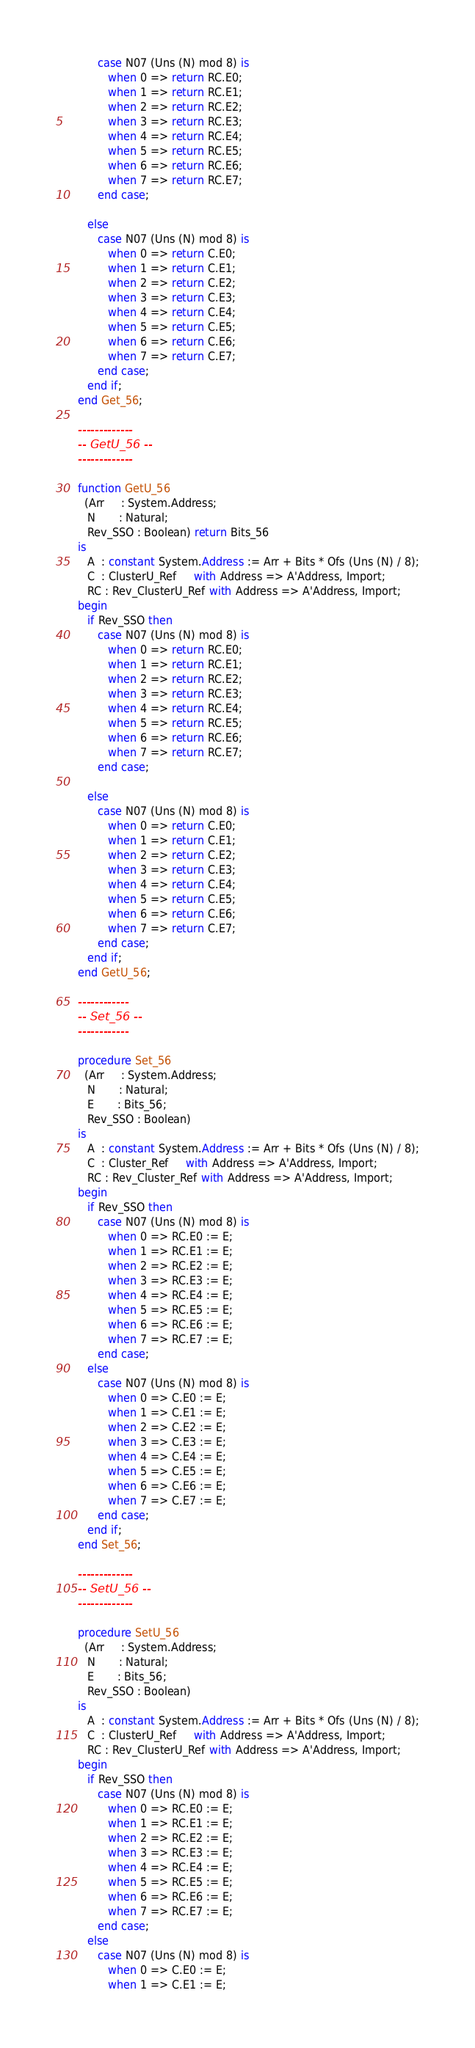<code> <loc_0><loc_0><loc_500><loc_500><_Ada_>         case N07 (Uns (N) mod 8) is
            when 0 => return RC.E0;
            when 1 => return RC.E1;
            when 2 => return RC.E2;
            when 3 => return RC.E3;
            when 4 => return RC.E4;
            when 5 => return RC.E5;
            when 6 => return RC.E6;
            when 7 => return RC.E7;
         end case;

      else
         case N07 (Uns (N) mod 8) is
            when 0 => return C.E0;
            when 1 => return C.E1;
            when 2 => return C.E2;
            when 3 => return C.E3;
            when 4 => return C.E4;
            when 5 => return C.E5;
            when 6 => return C.E6;
            when 7 => return C.E7;
         end case;
      end if;
   end Get_56;

   -------------
   -- GetU_56 --
   -------------

   function GetU_56
     (Arr     : System.Address;
      N       : Natural;
      Rev_SSO : Boolean) return Bits_56
   is
      A  : constant System.Address := Arr + Bits * Ofs (Uns (N) / 8);
      C  : ClusterU_Ref     with Address => A'Address, Import;
      RC : Rev_ClusterU_Ref with Address => A'Address, Import;
   begin
      if Rev_SSO then
         case N07 (Uns (N) mod 8) is
            when 0 => return RC.E0;
            when 1 => return RC.E1;
            when 2 => return RC.E2;
            when 3 => return RC.E3;
            when 4 => return RC.E4;
            when 5 => return RC.E5;
            when 6 => return RC.E6;
            when 7 => return RC.E7;
         end case;

      else
         case N07 (Uns (N) mod 8) is
            when 0 => return C.E0;
            when 1 => return C.E1;
            when 2 => return C.E2;
            when 3 => return C.E3;
            when 4 => return C.E4;
            when 5 => return C.E5;
            when 6 => return C.E6;
            when 7 => return C.E7;
         end case;
      end if;
   end GetU_56;

   ------------
   -- Set_56 --
   ------------

   procedure Set_56
     (Arr     : System.Address;
      N       : Natural;
      E       : Bits_56;
      Rev_SSO : Boolean)
   is
      A  : constant System.Address := Arr + Bits * Ofs (Uns (N) / 8);
      C  : Cluster_Ref     with Address => A'Address, Import;
      RC : Rev_Cluster_Ref with Address => A'Address, Import;
   begin
      if Rev_SSO then
         case N07 (Uns (N) mod 8) is
            when 0 => RC.E0 := E;
            when 1 => RC.E1 := E;
            when 2 => RC.E2 := E;
            when 3 => RC.E3 := E;
            when 4 => RC.E4 := E;
            when 5 => RC.E5 := E;
            when 6 => RC.E6 := E;
            when 7 => RC.E7 := E;
         end case;
      else
         case N07 (Uns (N) mod 8) is
            when 0 => C.E0 := E;
            when 1 => C.E1 := E;
            when 2 => C.E2 := E;
            when 3 => C.E3 := E;
            when 4 => C.E4 := E;
            when 5 => C.E5 := E;
            when 6 => C.E6 := E;
            when 7 => C.E7 := E;
         end case;
      end if;
   end Set_56;

   -------------
   -- SetU_56 --
   -------------

   procedure SetU_56
     (Arr     : System.Address;
      N       : Natural;
      E       : Bits_56;
      Rev_SSO : Boolean)
   is
      A  : constant System.Address := Arr + Bits * Ofs (Uns (N) / 8);
      C  : ClusterU_Ref     with Address => A'Address, Import;
      RC : Rev_ClusterU_Ref with Address => A'Address, Import;
   begin
      if Rev_SSO then
         case N07 (Uns (N) mod 8) is
            when 0 => RC.E0 := E;
            when 1 => RC.E1 := E;
            when 2 => RC.E2 := E;
            when 3 => RC.E3 := E;
            when 4 => RC.E4 := E;
            when 5 => RC.E5 := E;
            when 6 => RC.E6 := E;
            when 7 => RC.E7 := E;
         end case;
      else
         case N07 (Uns (N) mod 8) is
            when 0 => C.E0 := E;
            when 1 => C.E1 := E;</code> 